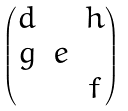Convert formula to latex. <formula><loc_0><loc_0><loc_500><loc_500>\begin{pmatrix} d & & h \\ g & e & \\ & & f \end{pmatrix}</formula> 